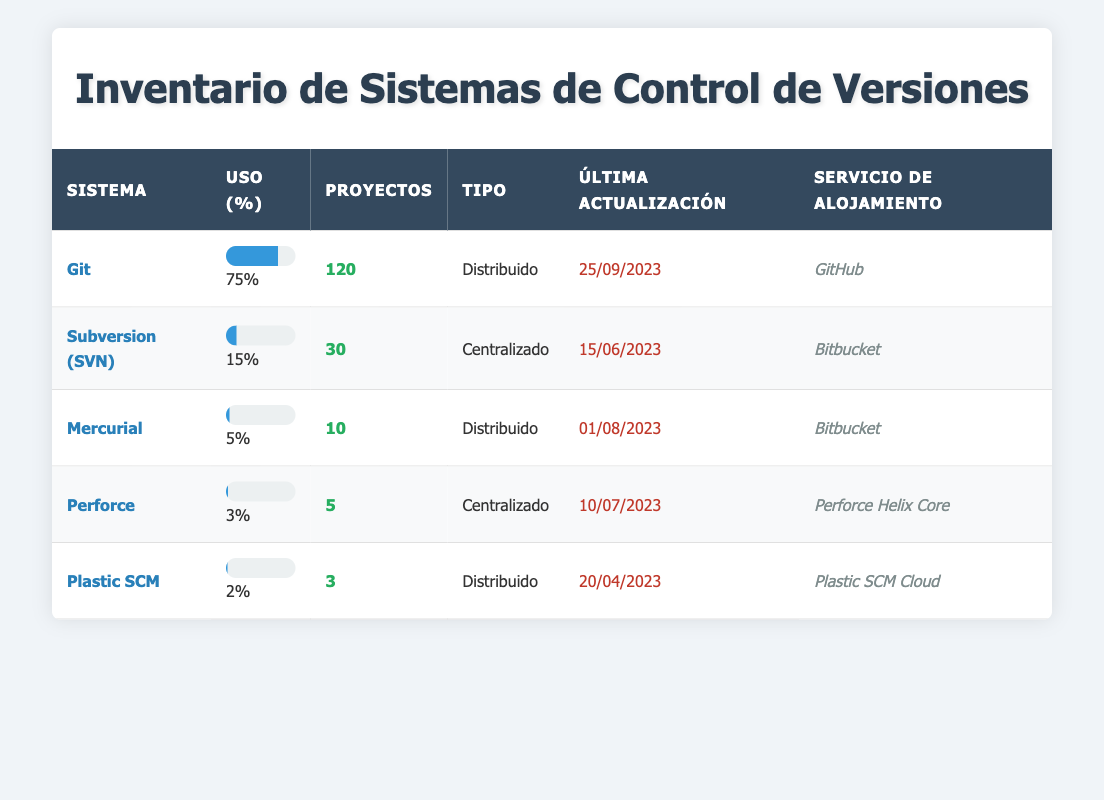¿Cuál es el sistema de control de versiones más utilizado en la empresa? En la tabla, el sistema con el porcentaje de uso más alto es Git, que tiene un 75% de uso.
Answer: Git ¿Cuántos proyectos utilizan Subversion (SVN)? En la columna "Proyectos", Subversion (SVN) tiene 30 proyectos asociados.
Answer: 30 ¿Existen sistemas de control de versiones distribuidos en la empresa? Sí, en la tabla se pueden ver tres sistemas distribuidos: Git, Mercurial y Plastic SCM.
Answer: Sí ¿Cuál es el porcentaje de uso de Mercurial? Para obtener esta información, debemos ver la columna "Uso (%)" correspondiente a Mercurial, la cual indica un 5%.
Answer: 5% ¿Cuántos proyectos en total utilizan sistemas de control de versiones centralizados? Debemos sumar los proyectos de Subversion (30) y Perforce (5), lo que da un total de 35 proyectos.
Answer: 35 ¿Es cierto que Plastic SCM es más utilizado que Perforce? Para verificar esto, comparamos los porcentajes de uso: Plastic SCM tiene un 2% y Perforce un 3%. Por lo tanto, se puede concluir que Plastic SCM no es más utilizado que Perforce.
Answer: No ¿Cuál es la última fecha de actualización de Git? En la tabla, la última actualización registrada para Git se muestra como 25 de septiembre de 2023.
Answer: 25/09/2023 ¿Cuántos sistemas tienen un uso inferior al 5%? Los sistemas con uso inferior al 5% son Mercurial (5%), Perforce (3%) y Plastic SCM (2%). Sin embargo, solo Perforce y Plastic SCM tienen un uso inferior a 5%. Entonces, hay 2 sistemas.
Answer: 2 ¿Cuál es el promedio de proyectos utilizados por sistema en la tabla? Hay 5 sistemas en total y sus proyectos son 120 (Git), 30 (SVN), 10 (Mercurial), 5 (Perforce), y 3 (Plastic SCM). La suma es 168 y el promedio se calcula dividiendo 168 entre 5, lo que da 33.6.
Answer: 33.6 